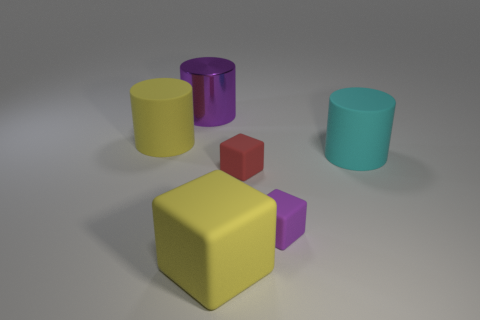Can you describe the lighting in the scene? The lighting in the scene is soft and diffused, coming from a source above the objects. It casts gentle shadows directly underneath them, indicating a single light source without strong directionality.  How might the lighting affect the perception of the objects' colors? The soft lighting helps maintain the true colors of the objects without causing strong reflections or high contrast which can sometimes distort color perception. Shadows are minimal, ensuring the colors remain consistent across the surfaces shown. 